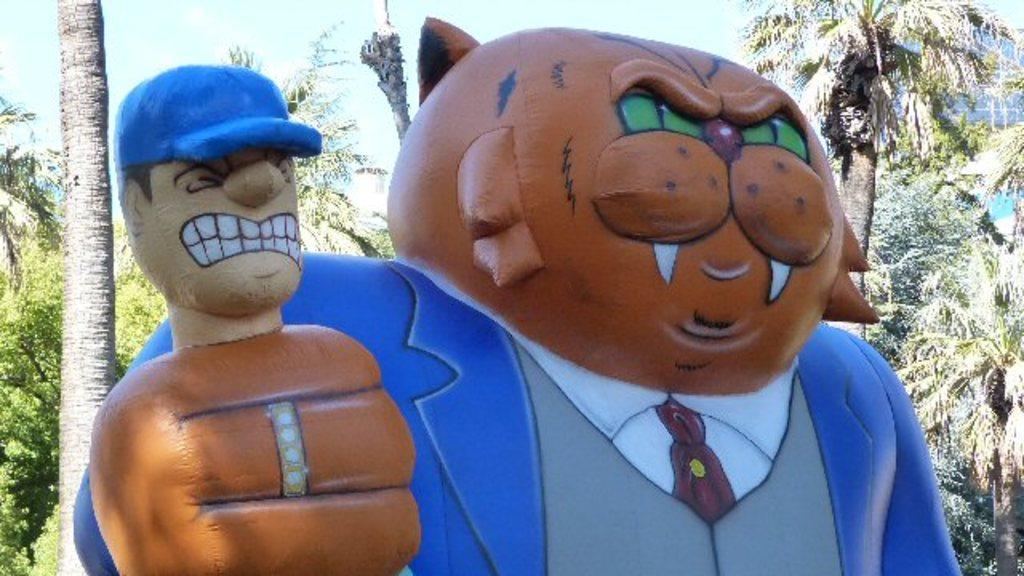What is the main subject in the picture? There is a statue in the picture. What other elements can be seen in the picture? There are trees in the picture. What can be seen in the background of the picture? The sky is visible in the background of the picture. What is the taste of the statue in the picture? The statue does not have a taste, as it is an inanimate object made of a material like stone or metal. 